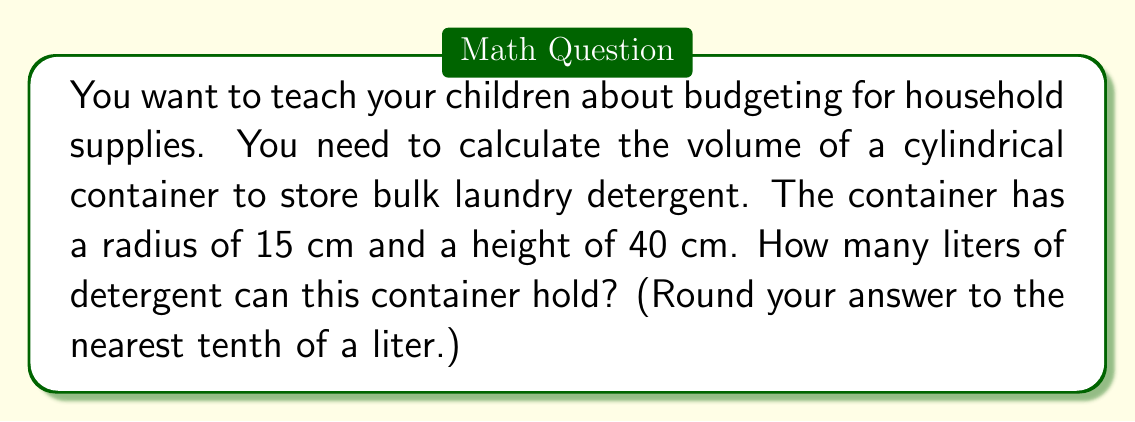What is the answer to this math problem? To solve this problem, we'll follow these steps:

1) The volume of a cylinder is given by the formula:
   
   $$V = \pi r^2 h$$

   where $r$ is the radius of the base and $h$ is the height of the cylinder.

2) We're given:
   $r = 15$ cm
   $h = 40$ cm

3) Let's substitute these values into our formula:

   $$V = \pi (15\text{ cm})^2 (40\text{ cm})$$

4) Simplify:
   $$V = \pi (225\text{ cm}^2) (40\text{ cm})$$
   $$V = 9000\pi\text{ cm}^3$$

5) Calculate:
   $$V \approx 28274.3\text{ cm}^3$$

6) Convert cubic centimeters to liters:
   1 liter = 1000 cm³, so we divide by 1000:

   $$28274.3\text{ cm}^3 \div 1000 = 28.2743\text{ liters}$$

7) Rounding to the nearest tenth of a liter:
   28.3 liters

[asy]
import geometry;

size(200);
real r = 3;
real h = 8;

path p = (r,0)--(r,h)--(-r,h)--(-r,0);
revolution cyl = revolution(p,Z);

draw(surface(cyl),lightgrey);
draw(p,black+1);

draw((r,0)--(r,h),black+1);
draw((-r,0)--(-r,h),black+1);
draw(circle((0,0),r),black+1);
draw(circle((0,h),r),black+1);

label("r",(r/2,0),S);
label("h",(r,h/2),E);

[/asy]
Answer: The cylindrical container can hold approximately 28.3 liters of laundry detergent. 